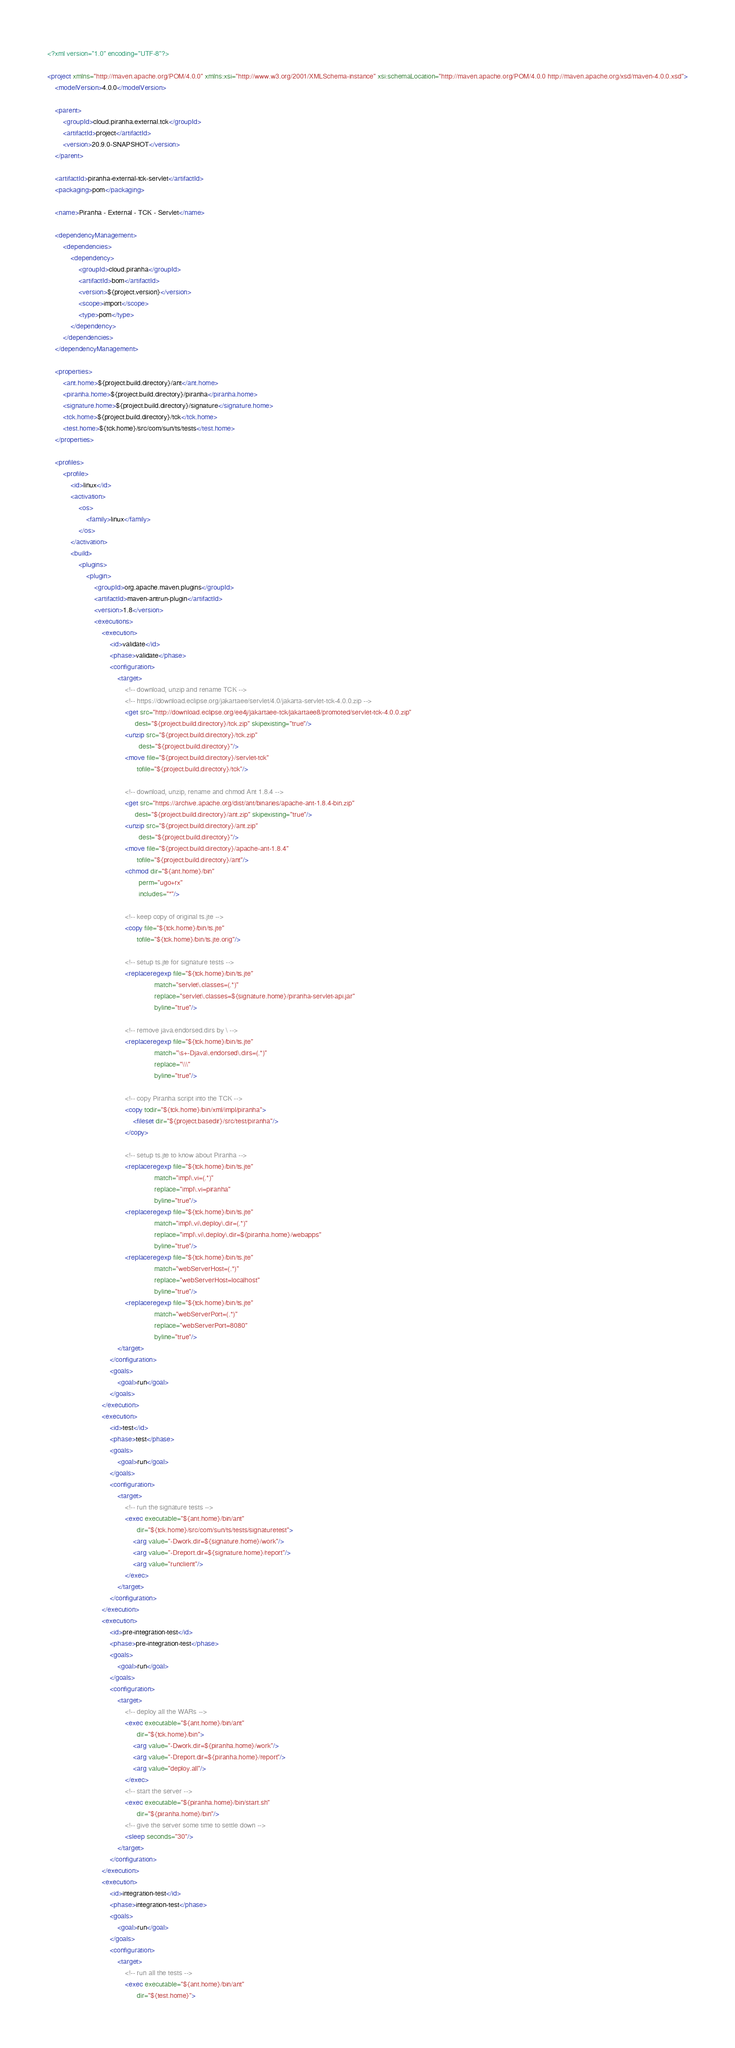Convert code to text. <code><loc_0><loc_0><loc_500><loc_500><_XML_><?xml version="1.0" encoding="UTF-8"?>

<project xmlns="http://maven.apache.org/POM/4.0.0" xmlns:xsi="http://www.w3.org/2001/XMLSchema-instance" xsi:schemaLocation="http://maven.apache.org/POM/4.0.0 http://maven.apache.org/xsd/maven-4.0.0.xsd">
    <modelVersion>4.0.0</modelVersion>

    <parent>
        <groupId>cloud.piranha.external.tck</groupId>
        <artifactId>project</artifactId>
        <version>20.9.0-SNAPSHOT</version>
    </parent>

    <artifactId>piranha-external-tck-servlet</artifactId>
    <packaging>pom</packaging>

    <name>Piranha - External - TCK - Servlet</name>

    <dependencyManagement>
        <dependencies>
            <dependency>
                <groupId>cloud.piranha</groupId>
                <artifactId>bom</artifactId>
                <version>${project.version}</version>
                <scope>import</scope>
                <type>pom</type>
            </dependency>
        </dependencies>
    </dependencyManagement>

    <properties>
        <ant.home>${project.build.directory}/ant</ant.home>
        <piranha.home>${project.build.directory}/piranha</piranha.home>
        <signature.home>${project.build.directory}/signature</signature.home>
        <tck.home>${project.build.directory}/tck</tck.home>
        <test.home>${tck.home}/src/com/sun/ts/tests</test.home>
    </properties>
    
    <profiles>
        <profile>
            <id>linux</id>
            <activation>
                <os>
                    <family>linux</family>
                </os>
            </activation>
            <build>
                <plugins>
                    <plugin>
                        <groupId>org.apache.maven.plugins</groupId>
                        <artifactId>maven-antrun-plugin</artifactId>
                        <version>1.8</version>
                        <executions>
                            <execution>
                                <id>validate</id>
                                <phase>validate</phase>
                                <configuration>
                                    <target>
                                        <!-- download, unzip and rename TCK -->
                                        <!-- https://download.eclipse.org/jakartaee/servlet/4.0/jakarta-servlet-tck-4.0.0.zip -->
                                        <get src="http://download.eclipse.org/ee4j/jakartaee-tck/jakartaee8/promoted/servlet-tck-4.0.0.zip"
                                             dest="${project.build.directory}/tck.zip" skipexisting="true"/>
                                        <unzip src="${project.build.directory}/tck.zip"
                                               dest="${project.build.directory}"/>
                                        <move file="${project.build.directory}/servlet-tck"
                                              tofile="${project.build.directory}/tck"/>
                                
                                        <!-- download, unzip, rename and chmod Ant 1.8.4 -->
                                        <get src="https://archive.apache.org/dist/ant/binaries/apache-ant-1.8.4-bin.zip"
                                             dest="${project.build.directory}/ant.zip" skipexisting="true"/>
                                        <unzip src="${project.build.directory}/ant.zip"
                                               dest="${project.build.directory}"/>
                                        <move file="${project.build.directory}/apache-ant-1.8.4"
                                              tofile="${project.build.directory}/ant"/>
                                        <chmod dir="${ant.home}/bin"
                                               perm="ugo+rx"
                                               includes="*"/>
                                
                                        <!-- keep copy of original ts.jte -->
                                        <copy file="${tck.home}/bin/ts.jte"
                                              tofile="${tck.home}/bin/ts.jte.orig"/> 
                                
                                        <!-- setup ts.jte for signature tests -->
                                        <replaceregexp file="${tck.home}/bin/ts.jte"
                                                       match="servlet\.classes=(.*)"
                                                       replace="servlet\.classes=${signature.home}/piranha-servlet-api.jar"
                                                       byline="true"/>
                                        
                                        <!-- remove java.endorsed.dirs by \ -->
                                        <replaceregexp file="${tck.home}/bin/ts.jte"
                                                       match="\s+-Djava\.endorsed\.dirs=(.*)"
                                                       replace="\\\"
                                                       byline="true"/>
                                
                                        <!-- copy Piranha script into the TCK -->
                                        <copy todir="${tck.home}/bin/xml/impl/piranha">
                                            <fileset dir="${project.basedir}/src/test/piranha"/>
                                        </copy>
                                
                                        <!-- setup ts.jte to know about Piranha -->
                                        <replaceregexp file="${tck.home}/bin/ts.jte"
                                                       match="impl\.vi=(.*)"
                                                       replace="impl\.vi=piranha"
                                                       byline="true"/>
                                        <replaceregexp file="${tck.home}/bin/ts.jte"
                                                       match="impl\.vi\.deploy\.dir=(.*)"
                                                       replace="impl\.vi\.deploy\.dir=${piranha.home}/webapps"
                                                       byline="true"/>
                                        <replaceregexp file="${tck.home}/bin/ts.jte"
                                                       match="webServerHost=(.*)"
                                                       replace="webServerHost=localhost"
                                                       byline="true"/>
                                        <replaceregexp file="${tck.home}/bin/ts.jte"
                                                       match="webServerPort=(.*)"
                                                       replace="webServerPort=8080"
                                                       byline="true"/>
                                    </target>
                                </configuration>
                                <goals>
                                    <goal>run</goal>
                                </goals>
                            </execution>
                            <execution>
                                <id>test</id>
                                <phase>test</phase>
                                <goals>
                                    <goal>run</goal>
                                </goals>
                                <configuration>
                                    <target>
                                        <!-- run the signature tests -->
                                        <exec executable="${ant.home}/bin/ant"
                                              dir="${tck.home}/src/com/sun/ts/tests/signaturetest">
                                            <arg value="-Dwork.dir=${signature.home}/work"/>
                                            <arg value="-Dreport.dir=${signature.home}/report"/>
                                            <arg value="runclient"/>
                                        </exec>
                                    </target>
                                </configuration>
                            </execution>
                            <execution>
                                <id>pre-integration-test</id>
                                <phase>pre-integration-test</phase>
                                <goals>
                                    <goal>run</goal>
                                </goals>
                                <configuration>
                                    <target>
                                        <!-- deploy all the WARs -->
                                        <exec executable="${ant.home}/bin/ant" 
                                              dir="${tck.home}/bin">
                                            <arg value="-Dwork.dir=${piranha.home}/work"/>
                                            <arg value="-Dreport.dir=${piranha.home}/report"/>
                                            <arg value="deploy.all"/>
                                        </exec>
                                        <!-- start the server -->
                                        <exec executable="${piranha.home}/bin/start.sh"
                                              dir="${piranha.home}/bin"/>
                                        <!-- give the server some time to settle down -->
                                        <sleep seconds="30"/>
                                    </target>
                                </configuration>
                            </execution>
                            <execution>
                                <id>integration-test</id>
                                <phase>integration-test</phase>
                                <goals>
                                    <goal>run</goal>
                                </goals>
                                <configuration>
                                    <target>
                                        <!-- run all the tests -->
                                        <exec executable="${ant.home}/bin/ant" 
                                              dir="${test.home}"></code> 